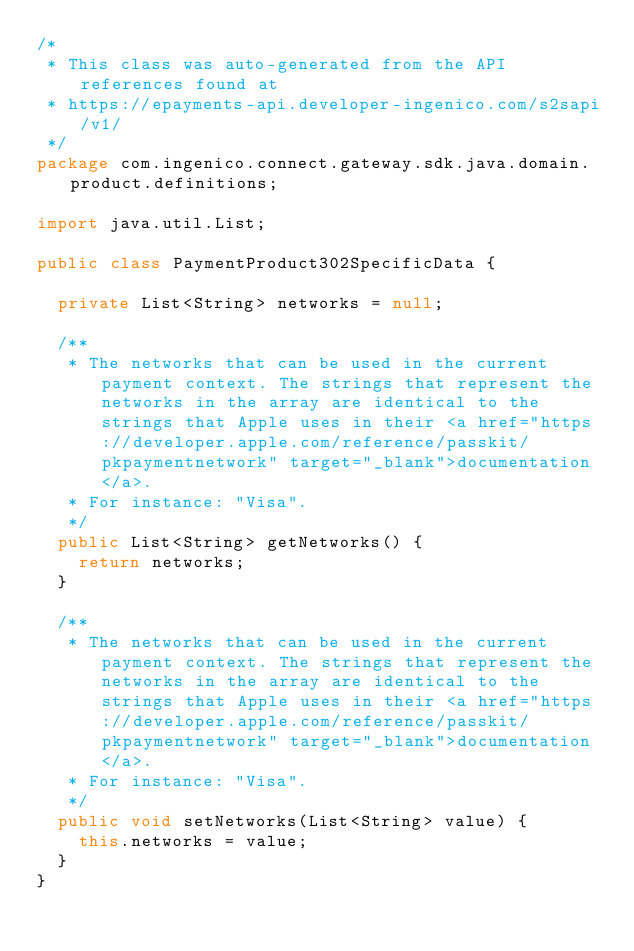Convert code to text. <code><loc_0><loc_0><loc_500><loc_500><_Java_>/*
 * This class was auto-generated from the API references found at
 * https://epayments-api.developer-ingenico.com/s2sapi/v1/
 */
package com.ingenico.connect.gateway.sdk.java.domain.product.definitions;

import java.util.List;

public class PaymentProduct302SpecificData {

	private List<String> networks = null;

	/**
	 * The networks that can be used in the current payment context. The strings that represent the networks in the array are identical to the strings that Apple uses in their <a href="https://developer.apple.com/reference/passkit/pkpaymentnetwork" target="_blank">documentation</a>.
	 * For instance: "Visa".
	 */
	public List<String> getNetworks() {
		return networks;
	}

	/**
	 * The networks that can be used in the current payment context. The strings that represent the networks in the array are identical to the strings that Apple uses in their <a href="https://developer.apple.com/reference/passkit/pkpaymentnetwork" target="_blank">documentation</a>.
	 * For instance: "Visa".
	 */
	public void setNetworks(List<String> value) {
		this.networks = value;
	}
}
</code> 